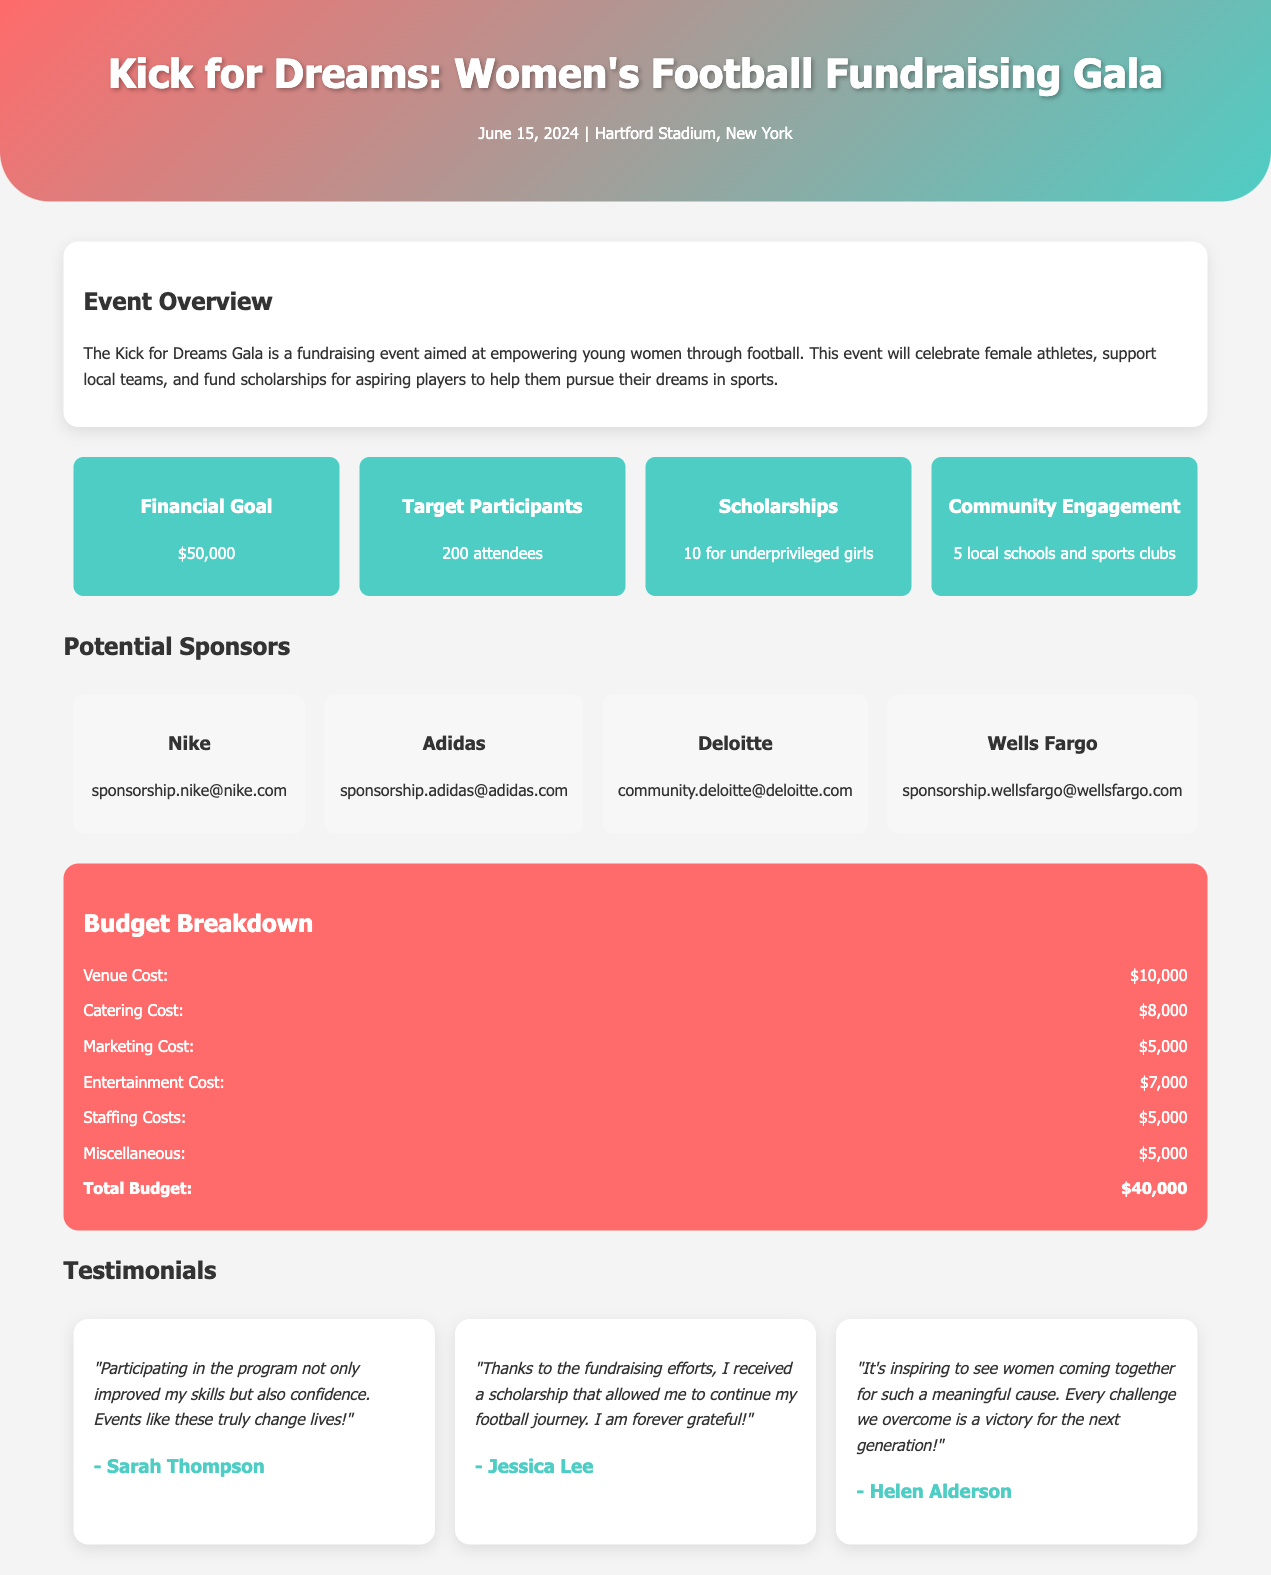What is the date of the event? The date of the event is clearly stated in the header section of the document.
Answer: June 15, 2024 What is the financial goal of the fundraising event? The financial goal is outlined in the goals section of the document.
Answer: $50,000 How many scholarships are planned for underprivileged girls? The goals section specifies the number of scholarships intended for underprivileged girls.
Answer: 10 What is the total budget for the event? The total budget can be found in the budget breakdown section, summing all costs listed.
Answer: $40,000 Which company is listed as a potential sponsor with a contact email starting with “sponsorship.nike”? The sponsors section includes Nike with its contact email.
Answer: Nike Which testimonial reflects a positive impact on confidence? The testimonials section contains a statement about improving skills and confidence.
Answer: Sarah Thompson Which category has the highest cost in the budget breakdown? The budget breakdown lists all costs, and the highest cost needs to be identified among them.
Answer: Venue Cost What is the main aim of the Kick for Dreams Gala as stated in the overview? The overview describes the event's main aim focusing on empowering young women through football.
Answer: Empowering young women Which participant expressed gratitude for receiving a scholarship? The testimonials section includes a specific statement regarding receiving a scholarship.
Answer: Jessica Lee 